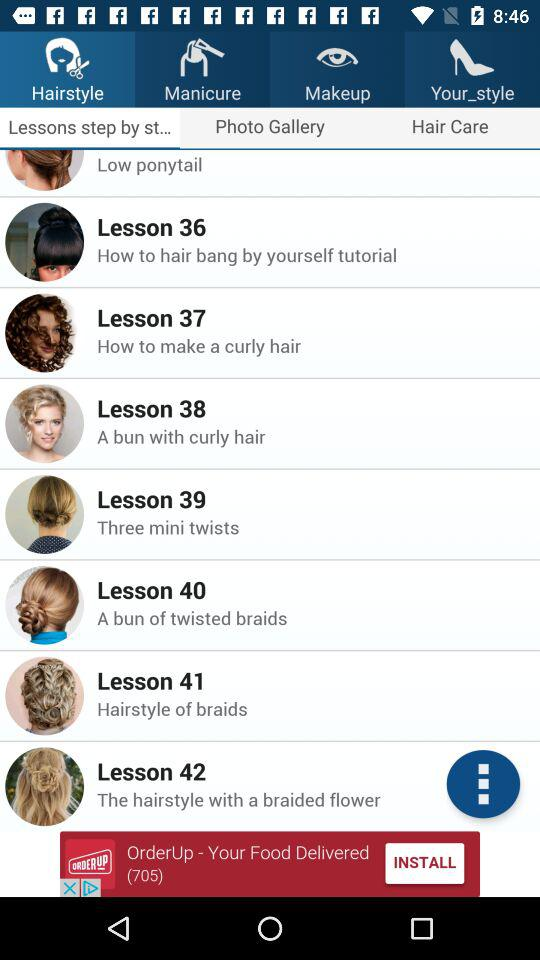How many lessons are there on this page that have a picture of a woman with curly hair?
Answer the question using a single word or phrase. 2 